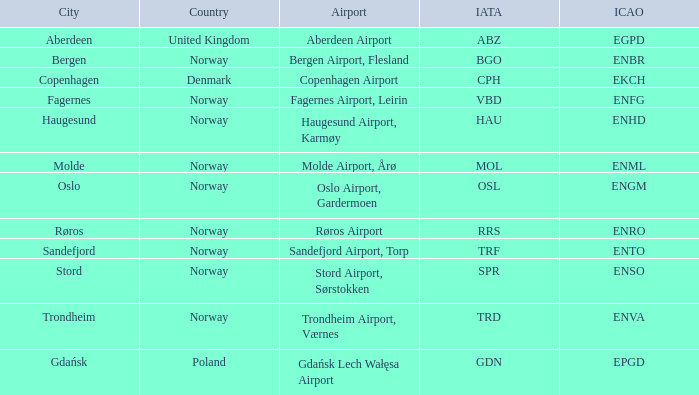What is the Airport in Oslo? Oslo Airport, Gardermoen. 